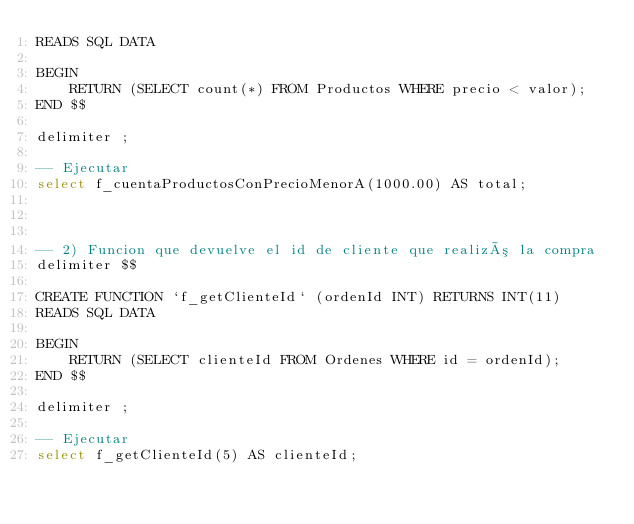<code> <loc_0><loc_0><loc_500><loc_500><_SQL_>READS SQL DATA

BEGIN
    RETURN (SELECT count(*) FROM Productos WHERE precio < valor);
END $$

delimiter ;

-- Ejecutar
select f_cuentaProductosConPrecioMenorA(1000.00) AS total;



-- 2) Funcion que devuelve el id de cliente que realizó la compra
delimiter $$

CREATE FUNCTION `f_getClienteId` (ordenId INT) RETURNS INT(11)
READS SQL DATA

BEGIN
	RETURN (SELECT clienteId FROM Ordenes WHERE id = ordenId);
END $$

delimiter ;

-- Ejecutar
select f_getClienteId(5) AS clienteId;</code> 